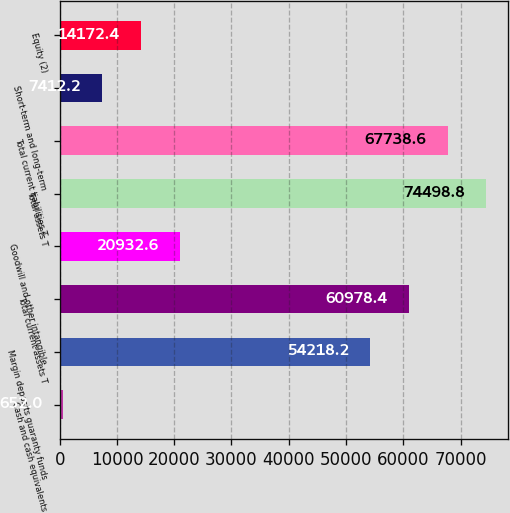Convert chart. <chart><loc_0><loc_0><loc_500><loc_500><bar_chart><fcel>Cash and cash equivalents<fcel>Margin deposits guaranty funds<fcel>Total current assets T<fcel>Goodwill and other intangible<fcel>Total assets T<fcel>Total current liabilities T<fcel>Short-term and long-term<fcel>Equity (2)<nl><fcel>652<fcel>54218.2<fcel>60978.4<fcel>20932.6<fcel>74498.8<fcel>67738.6<fcel>7412.2<fcel>14172.4<nl></chart> 